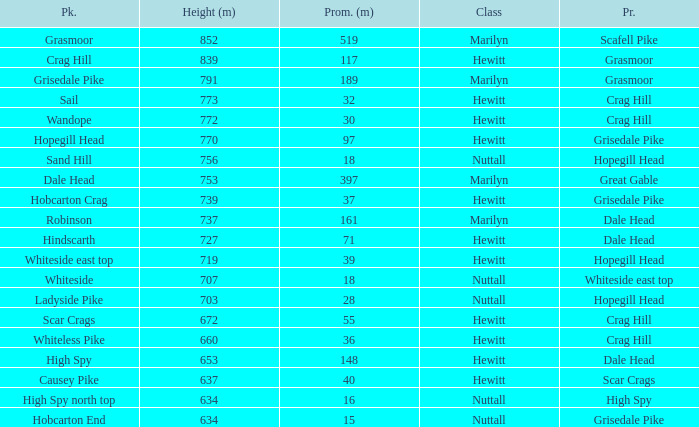Which Class is Peak Sail when it has a Prom larger than 30? Hewitt. 